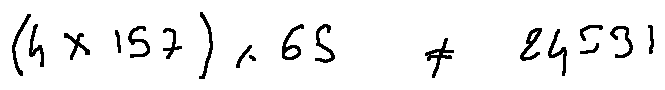Convert formula to latex. <formula><loc_0><loc_0><loc_500><loc_500>( 4 \times 1 5 7 ) \times 6 5 \neq 2 4 5 3 1</formula> 